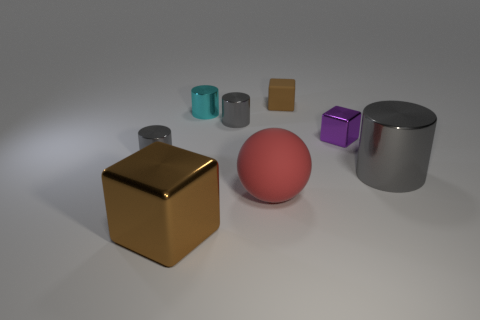How many small things are red cubes or metallic cylinders?
Your answer should be very brief. 3. Is there a purple block that has the same size as the red matte object?
Ensure brevity in your answer.  No. There is a tiny shiny thing that is on the right side of the small gray cylinder that is behind the gray metal cylinder that is left of the large brown shiny object; what is its color?
Keep it short and to the point. Purple. Are the large brown block and the tiny thing in front of the purple thing made of the same material?
Offer a very short reply. Yes. What is the size of the cyan thing that is the same shape as the large gray metallic thing?
Keep it short and to the point. Small. Is the number of small cylinders that are on the right side of the large matte thing the same as the number of large metal cylinders that are behind the small purple shiny cube?
Your response must be concise. Yes. What number of other objects are there of the same material as the red thing?
Make the answer very short. 1. Is the number of brown shiny things that are right of the large red matte sphere the same as the number of gray shiny spheres?
Your answer should be very brief. Yes. There is a red sphere; is it the same size as the block in front of the ball?
Make the answer very short. Yes. There is a tiny metallic thing on the right side of the matte ball; what is its shape?
Your response must be concise. Cube. 